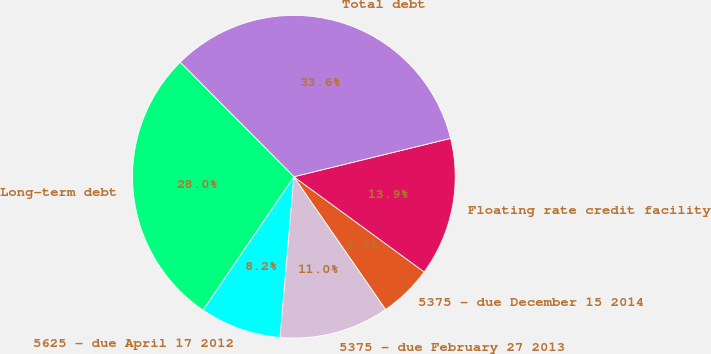Convert chart to OTSL. <chart><loc_0><loc_0><loc_500><loc_500><pie_chart><fcel>5625 - due April 17 2012<fcel>5375 - due February 27 2013<fcel>5375 - due December 15 2014<fcel>Floating rate credit facility<fcel>Total debt<fcel>Long-term debt<nl><fcel>8.16%<fcel>10.99%<fcel>5.33%<fcel>13.86%<fcel>33.62%<fcel>28.03%<nl></chart> 